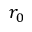<formula> <loc_0><loc_0><loc_500><loc_500>r _ { 0 }</formula> 